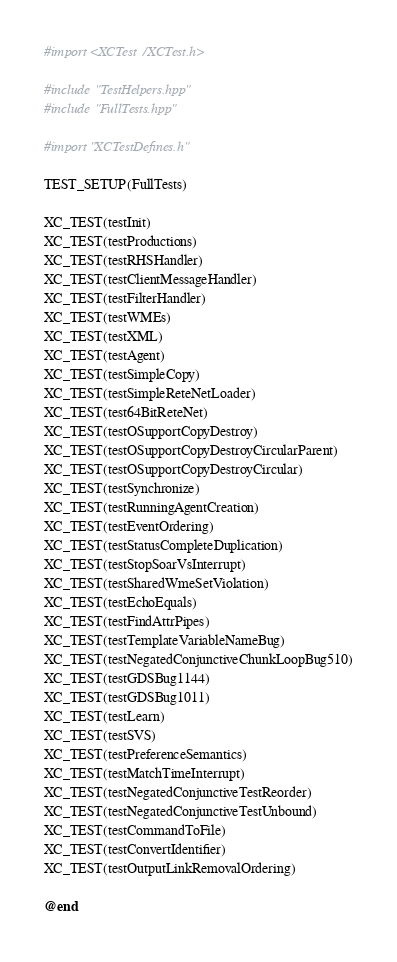<code> <loc_0><loc_0><loc_500><loc_500><_ObjectiveC_>#import <XCTest/XCTest.h>

#include "TestHelpers.hpp"
#include "FullTests.hpp"

#import "XCTestDefines.h"

TEST_SETUP(FullTests)

XC_TEST(testInit)
XC_TEST(testProductions)
XC_TEST(testRHSHandler)
XC_TEST(testClientMessageHandler)
XC_TEST(testFilterHandler)
XC_TEST(testWMEs)
XC_TEST(testXML)
XC_TEST(testAgent)
XC_TEST(testSimpleCopy)
XC_TEST(testSimpleReteNetLoader)
XC_TEST(test64BitReteNet)
XC_TEST(testOSupportCopyDestroy)
XC_TEST(testOSupportCopyDestroyCircularParent)
XC_TEST(testOSupportCopyDestroyCircular)
XC_TEST(testSynchronize)
XC_TEST(testRunningAgentCreation)
XC_TEST(testEventOrdering)
XC_TEST(testStatusCompleteDuplication)
XC_TEST(testStopSoarVsInterrupt)
XC_TEST(testSharedWmeSetViolation)
XC_TEST(testEchoEquals)
XC_TEST(testFindAttrPipes)
XC_TEST(testTemplateVariableNameBug)
XC_TEST(testNegatedConjunctiveChunkLoopBug510)
XC_TEST(testGDSBug1144)
XC_TEST(testGDSBug1011)
XC_TEST(testLearn)
XC_TEST(testSVS)
XC_TEST(testPreferenceSemantics)
XC_TEST(testMatchTimeInterrupt)
XC_TEST(testNegatedConjunctiveTestReorder)
XC_TEST(testNegatedConjunctiveTestUnbound)
XC_TEST(testCommandToFile)
XC_TEST(testConvertIdentifier)
XC_TEST(testOutputLinkRemovalOrdering)

@end
</code> 